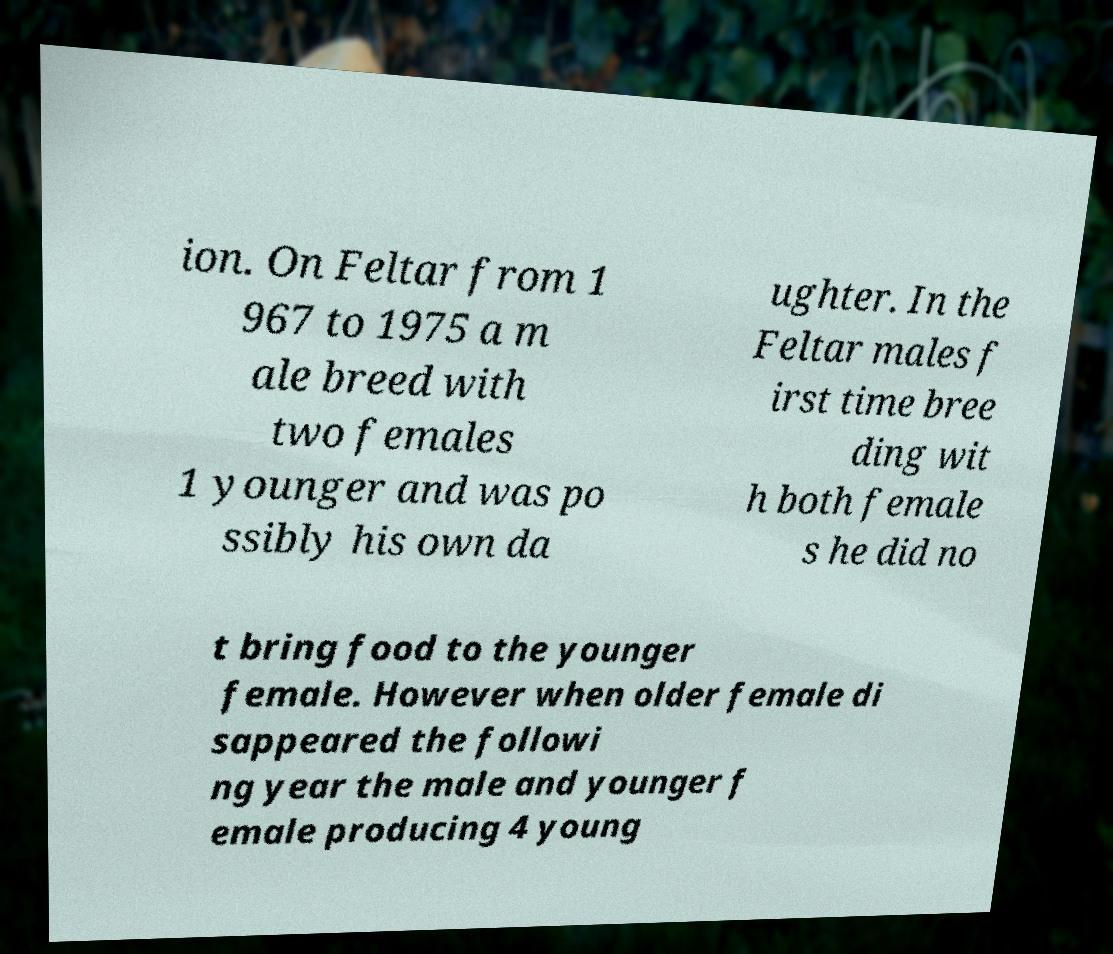I need the written content from this picture converted into text. Can you do that? ion. On Feltar from 1 967 to 1975 a m ale breed with two females 1 younger and was po ssibly his own da ughter. In the Feltar males f irst time bree ding wit h both female s he did no t bring food to the younger female. However when older female di sappeared the followi ng year the male and younger f emale producing 4 young 